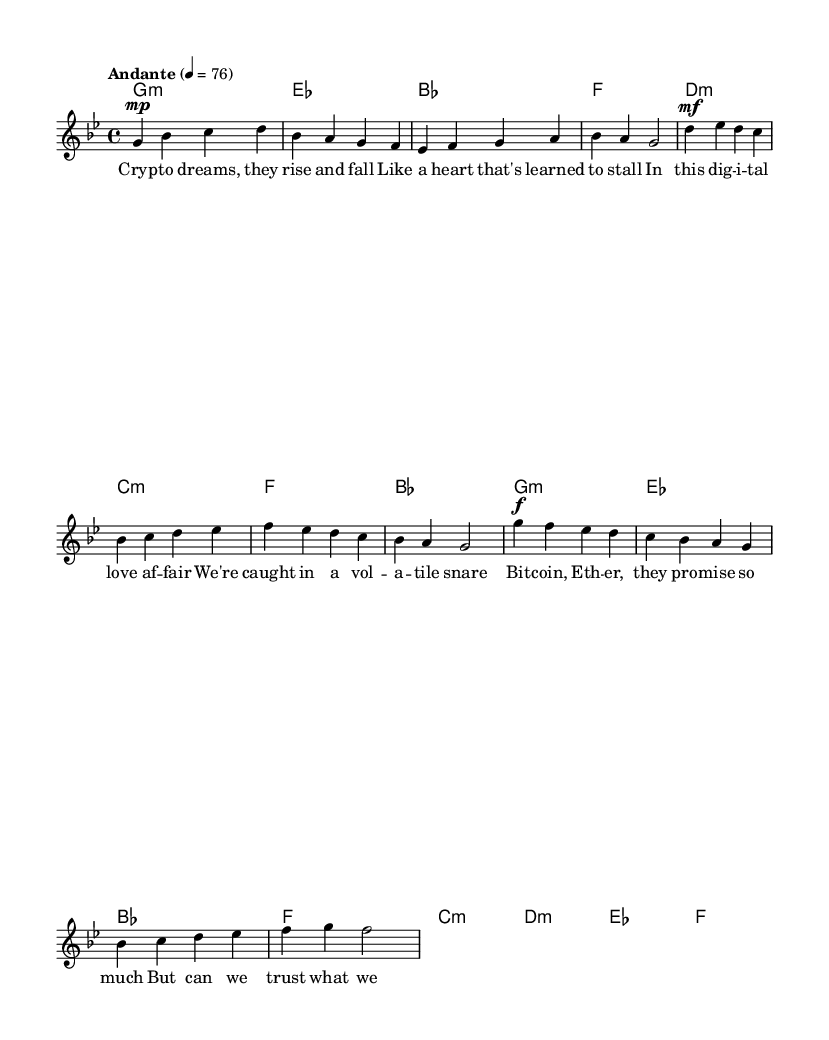What is the key signature of this music? The key signature is G minor, which has two flats (B flat and E flat). This can be identified by looking at the key signature notated at the beginning of the staff.
Answer: G minor What is the time signature of the piece? The time signature is 4/4, indicating that there are four beats per measure and the quarter note gets one beat. This is indicated at the beginning of the piece next to the key signature.
Answer: 4/4 What is the tempo marking of this music? The tempo is marked as "Andante" with a metronome marking of 76, meaning it should be performed at a moderate walking speed. This is specified in the tempo indication found on the score.
Answer: Andante 76 What do the dynamics in the verse indicate? The dynamics in the verse start at mezzo-piano (mp), indicating a moderately soft volume. This is noted at the beginning of the verse section, guiding the performer on the intended intensity of that part.
Answer: Mezzo-piano How many measures are in the chorus? The chorus consists of four measures, which is determined by counting the bar lines (vertical lines) at the beginning and end of each measure in the chorus section.
Answer: Four What is the lyrical theme of the chorus? The lyrical theme of the chorus revolves around skepticism and caution regarding the promises made by cryptocurrencies. The lyrics explicitly question the trustworthiness of things that cannot be physically touched. This can be inferred from the content of the lyrics placed under the music notes.
Answer: Skepticism towards cryptocurrencies What type of music structure is used in this K-pop ballad? The music structure follows a typical pop song layout, consisting of verses, a pre-chorus, and a chorus. This structure is common in K-pop ballads, facilitating emotional storytelling through music. This can be inferred from the labeled sections of the score.
Answer: Verse - Pre-Chorus - Chorus 